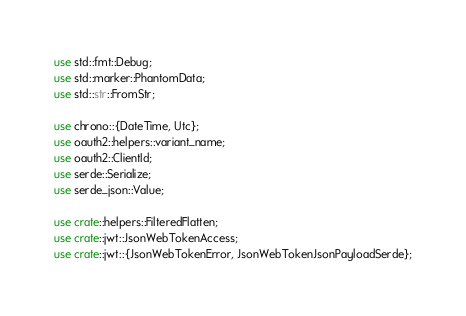Convert code to text. <code><loc_0><loc_0><loc_500><loc_500><_Rust_>use std::fmt::Debug;
use std::marker::PhantomData;
use std::str::FromStr;

use chrono::{DateTime, Utc};
use oauth2::helpers::variant_name;
use oauth2::ClientId;
use serde::Serialize;
use serde_json::Value;

use crate::helpers::FilteredFlatten;
use crate::jwt::JsonWebTokenAccess;
use crate::jwt::{JsonWebTokenError, JsonWebTokenJsonPayloadSerde};</code> 